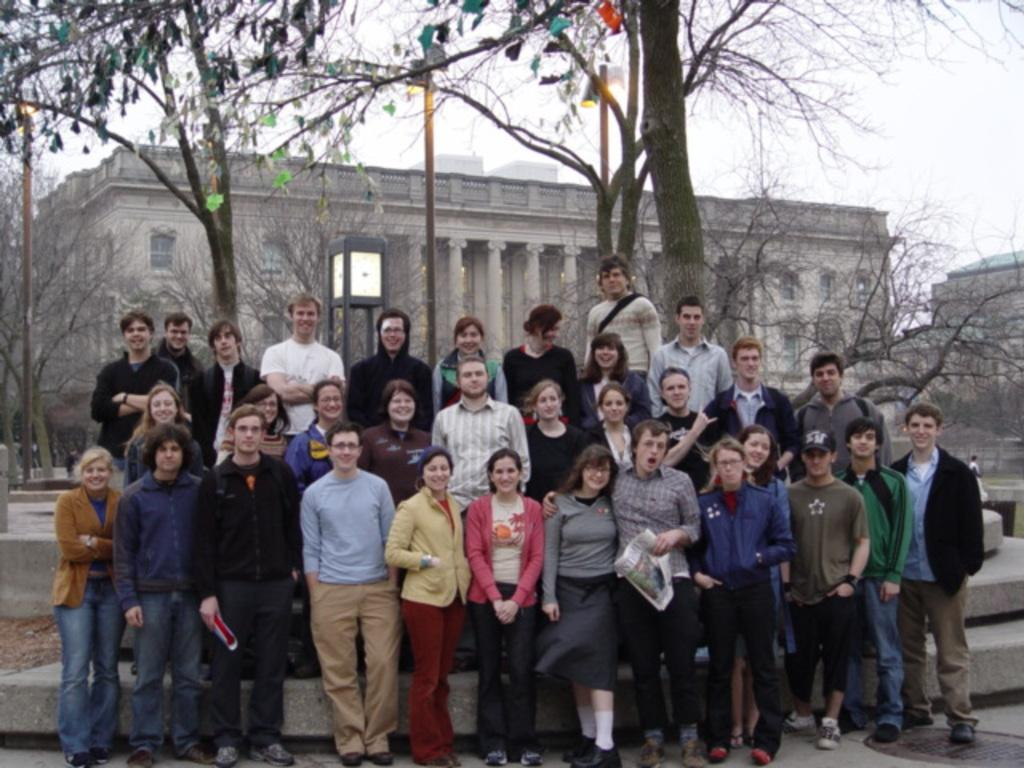How many people are in the image? There is a group of people standing in the image. What is the facial expression of the people in the image? The people are smiling. What architectural feature is visible behind the group of people? There are stairs behind the group of people. What type of barrier is present behind the group of people? Concrete fences are visible behind the group of people. What type of vegetation can be seen in the background of the image? Trees are present in the background of the image. What type of lighting is visible in the background of the image? Lamp posts are visible in the background of the image. What type of structures can be seen in the background of the image? There are buildings in the background of the image. What type of crown is the person wearing in the image? There is no crown present in the image; the people are not wearing any headwear. 